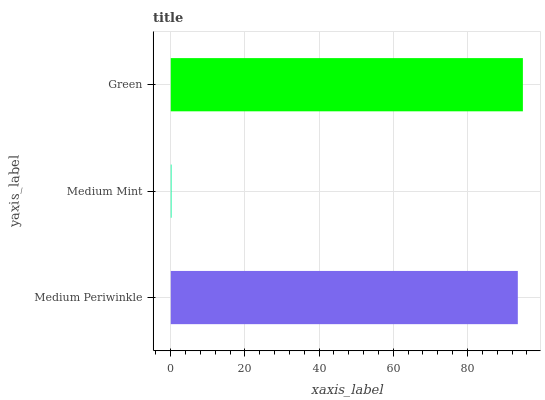Is Medium Mint the minimum?
Answer yes or no. Yes. Is Green the maximum?
Answer yes or no. Yes. Is Green the minimum?
Answer yes or no. No. Is Medium Mint the maximum?
Answer yes or no. No. Is Green greater than Medium Mint?
Answer yes or no. Yes. Is Medium Mint less than Green?
Answer yes or no. Yes. Is Medium Mint greater than Green?
Answer yes or no. No. Is Green less than Medium Mint?
Answer yes or no. No. Is Medium Periwinkle the high median?
Answer yes or no. Yes. Is Medium Periwinkle the low median?
Answer yes or no. Yes. Is Medium Mint the high median?
Answer yes or no. No. Is Green the low median?
Answer yes or no. No. 